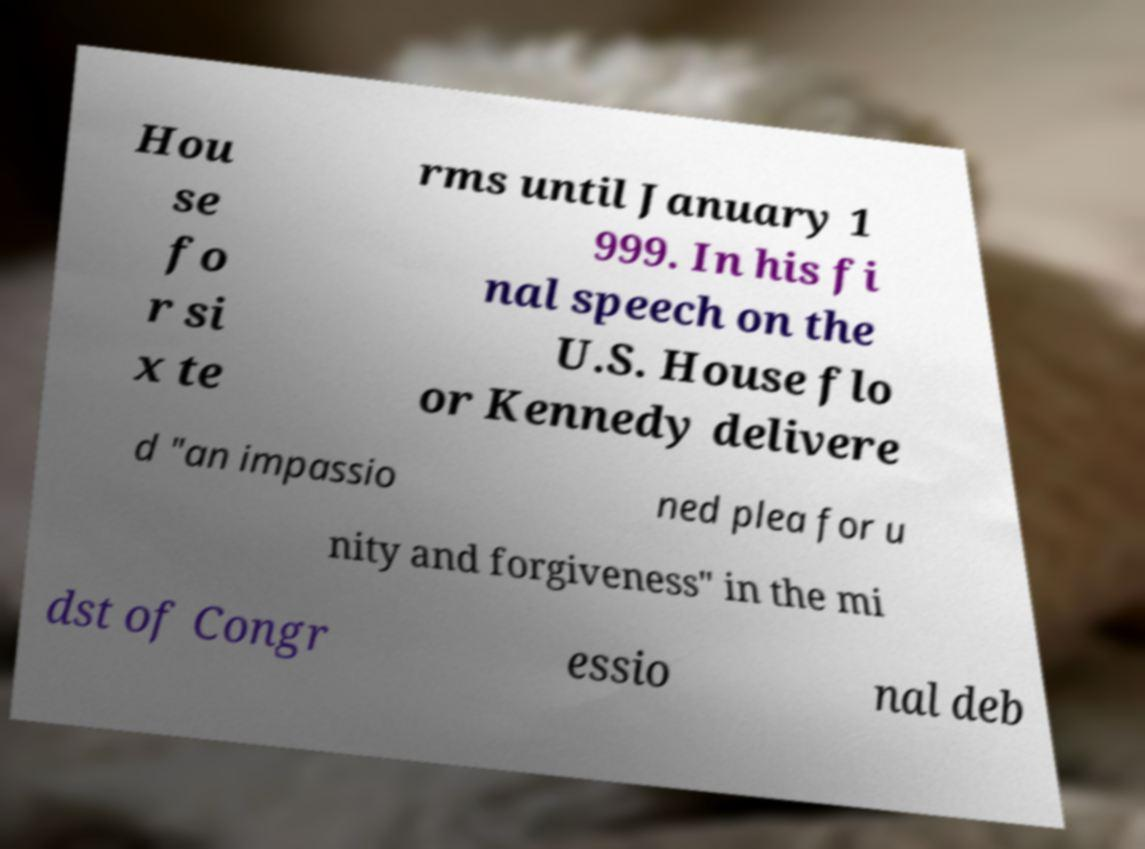Please read and relay the text visible in this image. What does it say? Hou se fo r si x te rms until January 1 999. In his fi nal speech on the U.S. House flo or Kennedy delivere d "an impassio ned plea for u nity and forgiveness" in the mi dst of Congr essio nal deb 